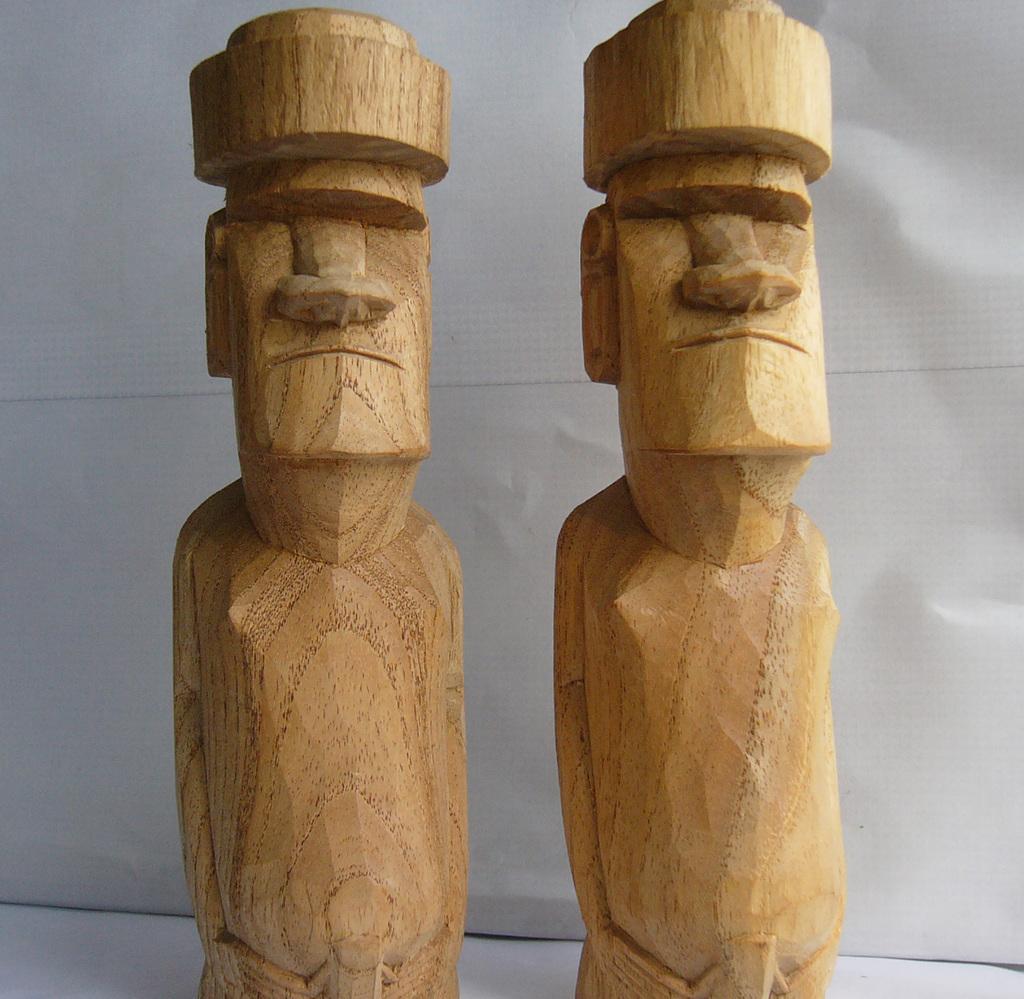Describe this image in one or two sentences. As we can see in the image there is white color wall and there are human statues made with wood. 